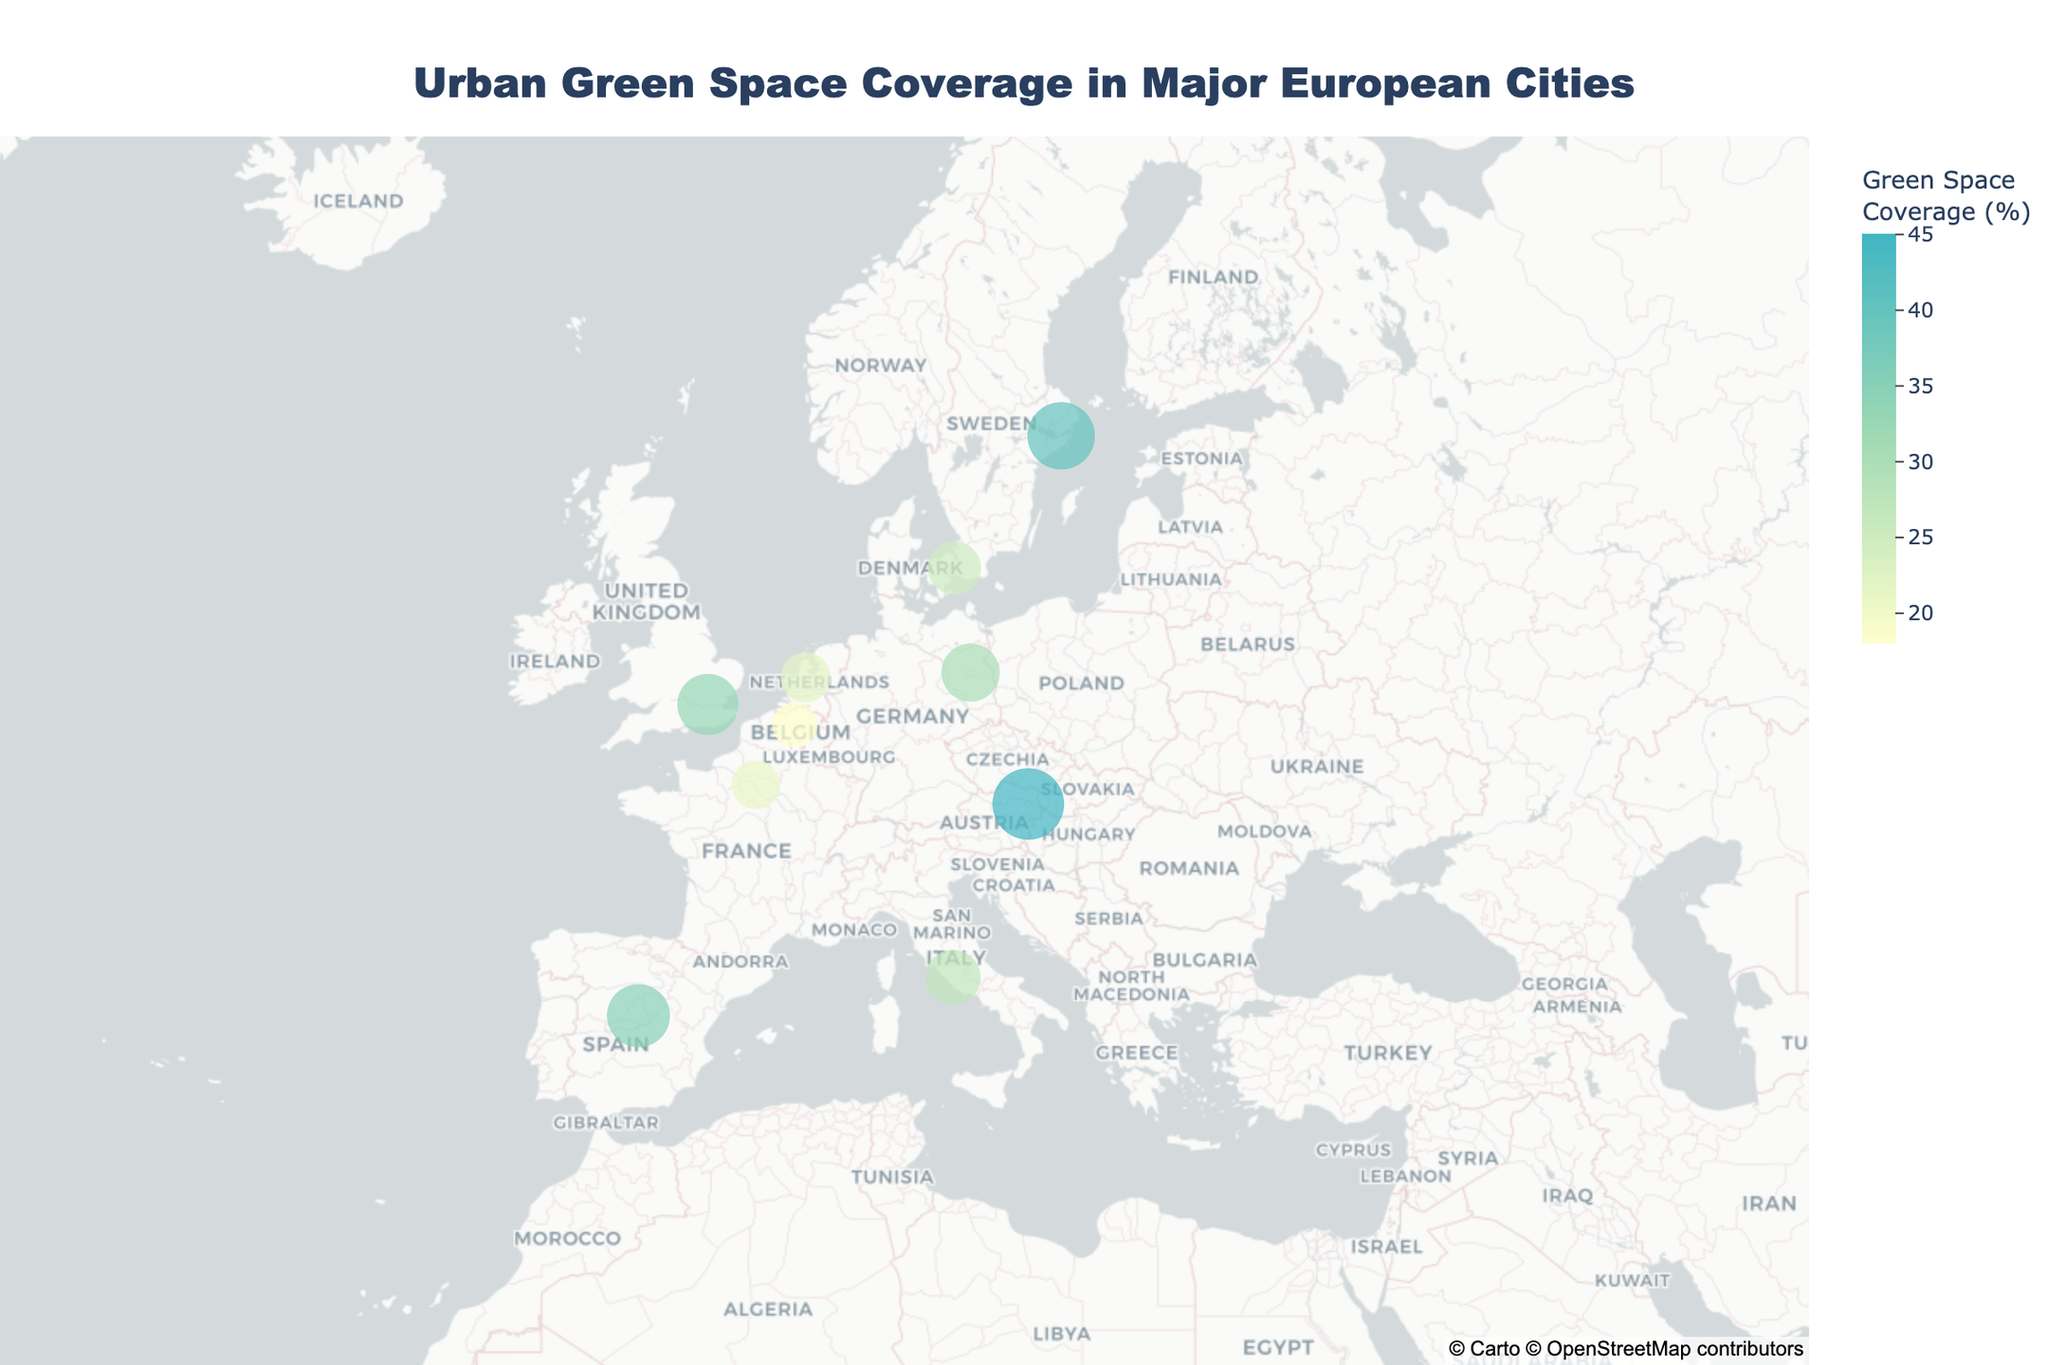What is the city with the highest green space coverage? First, identify the data plotted for each city. Notice that Vienna has the largest circle size representing green space coverage, indicating the highest percentage.
Answer: Vienna Which country has the city with the lowest green space coverage? Refer to the data points and look for the smallest circle size. Brussels in Belgium has the smallest size, indicating the lowest green space coverage at 18%.
Answer: Belgium What is the range of green space coverage percentages shown in the figure? Identify the smallest and largest green space coverage values: Brussels has the lowest at 18%, and Vienna has the highest at 45%. Subtract the smallest from the largest to find the range.
Answer: 27% What are the major parks in Berlin? Find Berlin on the map and access the hover data, which lists the major parks.
Answer: Tiergarten How does the green space coverage of Madrid compare to that of Paris? Compare the sizes of the circles representing green space coverage for Madrid (35%) and Paris (21%). Madrid has a higher green space coverage.
Answer: Madrid has more Which city has the highest latitude, and what is its green space coverage percentage? Identify the city plotted highest on the map (most northward), which is Stockholm. Check its circle size and hover data for green space coverage.
Answer: Stockholm, 40% What is the average green space coverage of the cities in Spain and Italy? Madrid (Spain) has 35%, and Rome (Italy) has 27%. The average is calculated by summing these percentages and dividing by the number of cities: (35 + 27)/2 = 31.
Answer: 31% Which cities are clustered geographically close to each other and have similar green space coverage percentages? Look for geographic proximity by observing which cities are plotted near each other and have similar circle sizes. Amsterdam (22%) and Brussels (18%) in the Netherlands/Belgium region seem close geographically with relatively similar coverages.
Answer: Amsterdam and Brussels What is the title of the figure? Locate the title text at the top of the figure.
Answer: Urban Green Space Coverage in Major European Cities What is the color scale used for the green space coverage, and how does it relate to the percentage values? Examine the color variation from light to dark shades on the map. It scales from light yellow (low green space coverage) to darker blue-green (high green space coverage).
Answer: Light yellow to blue-green 